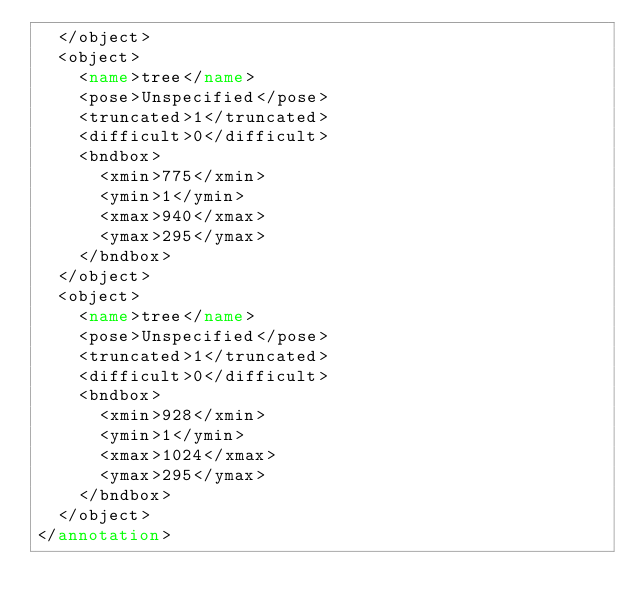Convert code to text. <code><loc_0><loc_0><loc_500><loc_500><_XML_>	</object>
	<object>
		<name>tree</name>
		<pose>Unspecified</pose>
		<truncated>1</truncated>
		<difficult>0</difficult>
		<bndbox>
			<xmin>775</xmin>
			<ymin>1</ymin>
			<xmax>940</xmax>
			<ymax>295</ymax>
		</bndbox>
	</object>
	<object>
		<name>tree</name>
		<pose>Unspecified</pose>
		<truncated>1</truncated>
		<difficult>0</difficult>
		<bndbox>
			<xmin>928</xmin>
			<ymin>1</ymin>
			<xmax>1024</xmax>
			<ymax>295</ymax>
		</bndbox>
	</object>
</annotation>
</code> 